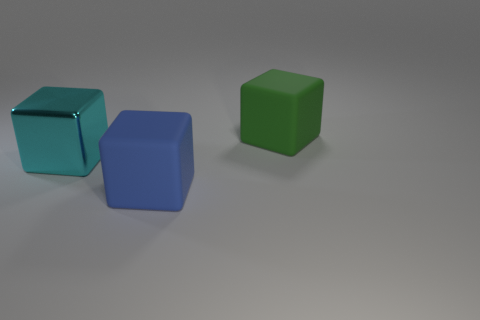Is there anything else that has the same material as the cyan block?
Your response must be concise. No. What number of other things are there of the same shape as the big cyan metallic object?
Ensure brevity in your answer.  2. Are there more large blue matte blocks than large green metal things?
Offer a terse response. Yes. Does the big blue thing have the same material as the cyan cube?
Your answer should be very brief. No. What number of brown balls have the same material as the big green thing?
Your response must be concise. 0. Do the green object and the blue rubber cube that is right of the metallic object have the same size?
Offer a very short reply. Yes. What is the color of the big object that is both in front of the big green cube and behind the large blue rubber cube?
Your response must be concise. Cyan. Is there a large block to the right of the matte cube that is in front of the big cyan thing?
Ensure brevity in your answer.  Yes. Are there an equal number of big blocks that are in front of the blue cube and tiny red blocks?
Provide a succinct answer. Yes. There is a rubber block that is in front of the large green rubber cube that is behind the large blue cube; what number of big things are to the left of it?
Give a very brief answer. 1. 